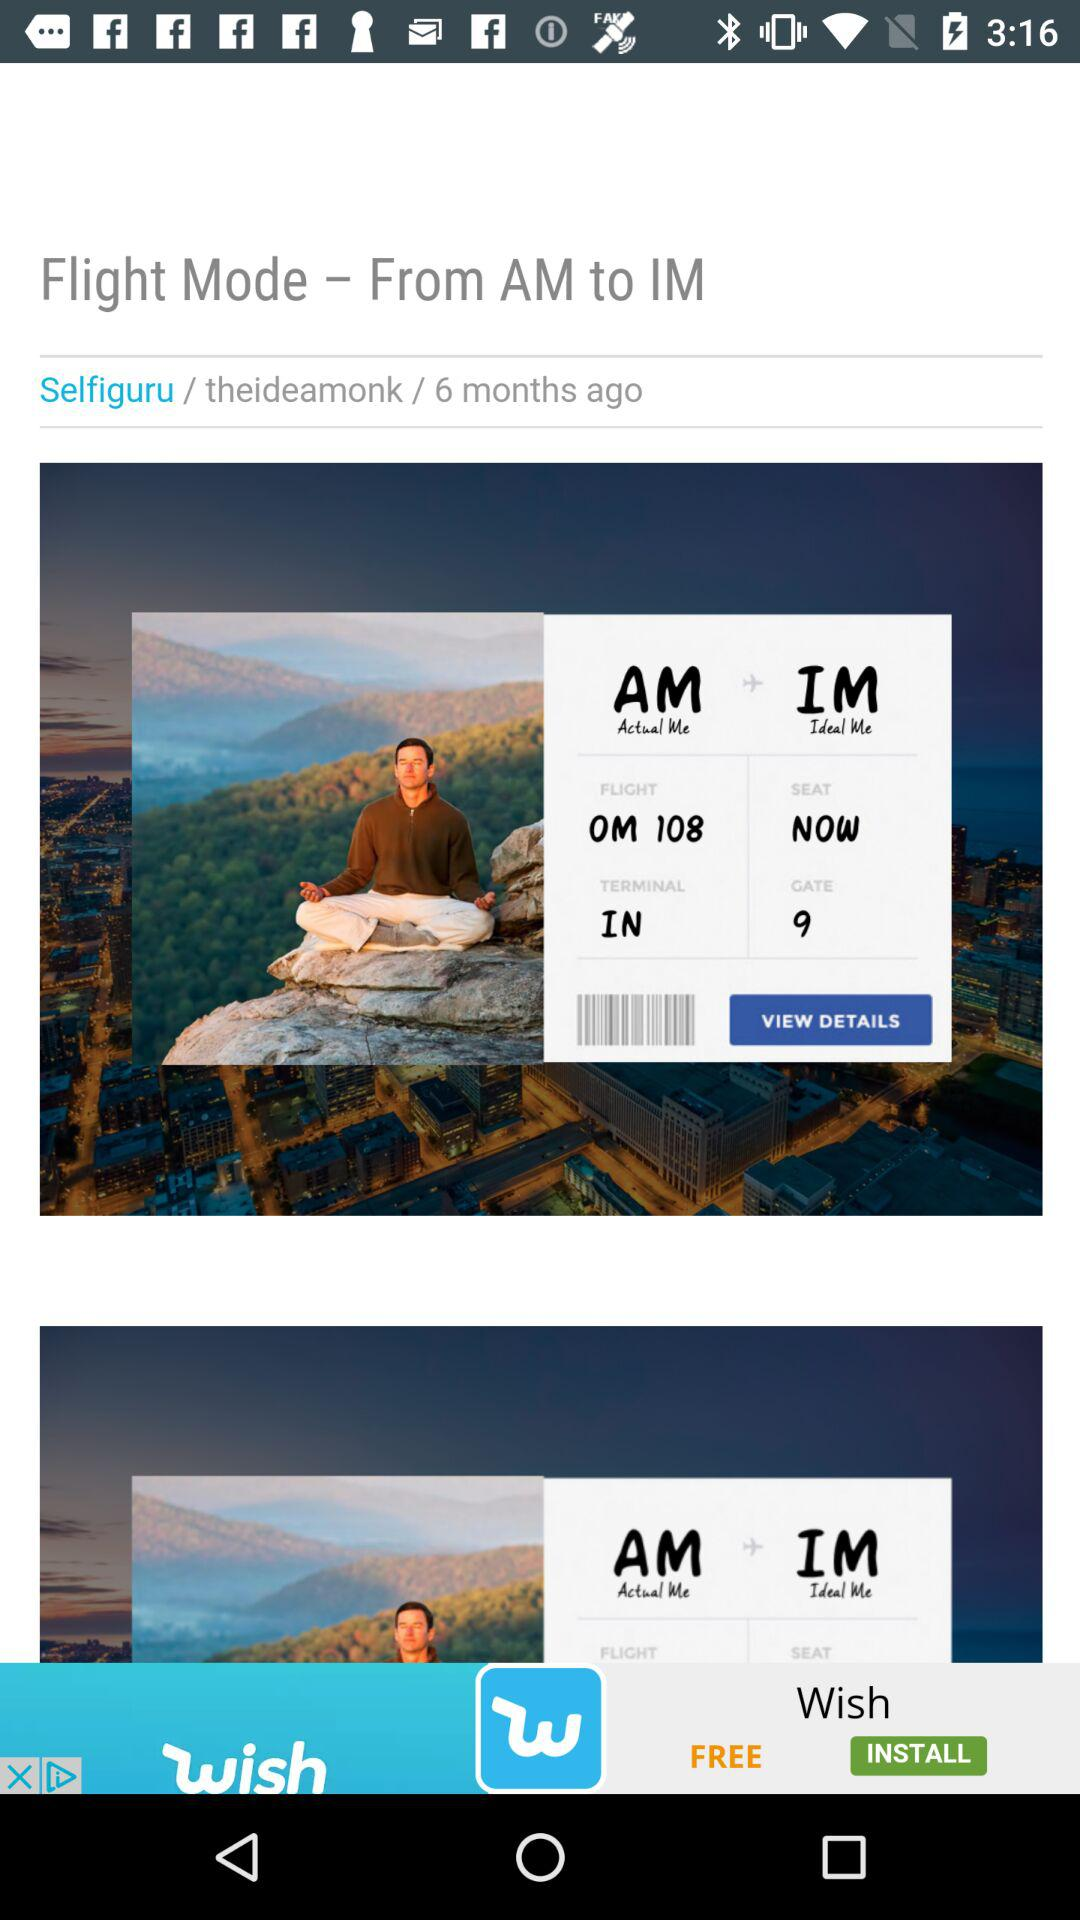When did Selfiguru post? The Selfiguru posted 6 months ago. 